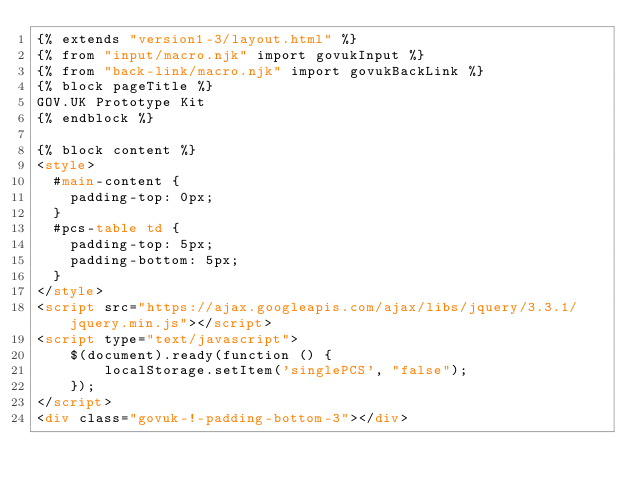<code> <loc_0><loc_0><loc_500><loc_500><_HTML_>{% extends "version1-3/layout.html" %}
{% from "input/macro.njk" import govukInput %}
{% from "back-link/macro.njk" import govukBackLink %}
{% block pageTitle %}
GOV.UK Prototype Kit
{% endblock %}

{% block content %}
<style>
  #main-content {
    padding-top: 0px;
  }
  #pcs-table td {
    padding-top: 5px;
    padding-bottom: 5px;
  }
</style>
<script src="https://ajax.googleapis.com/ajax/libs/jquery/3.3.1/jquery.min.js"></script>
<script type="text/javascript">
    $(document).ready(function () {
        localStorage.setItem('singlePCS', "false");
    });
</script>
<div class="govuk-!-padding-bottom-3"></div></code> 